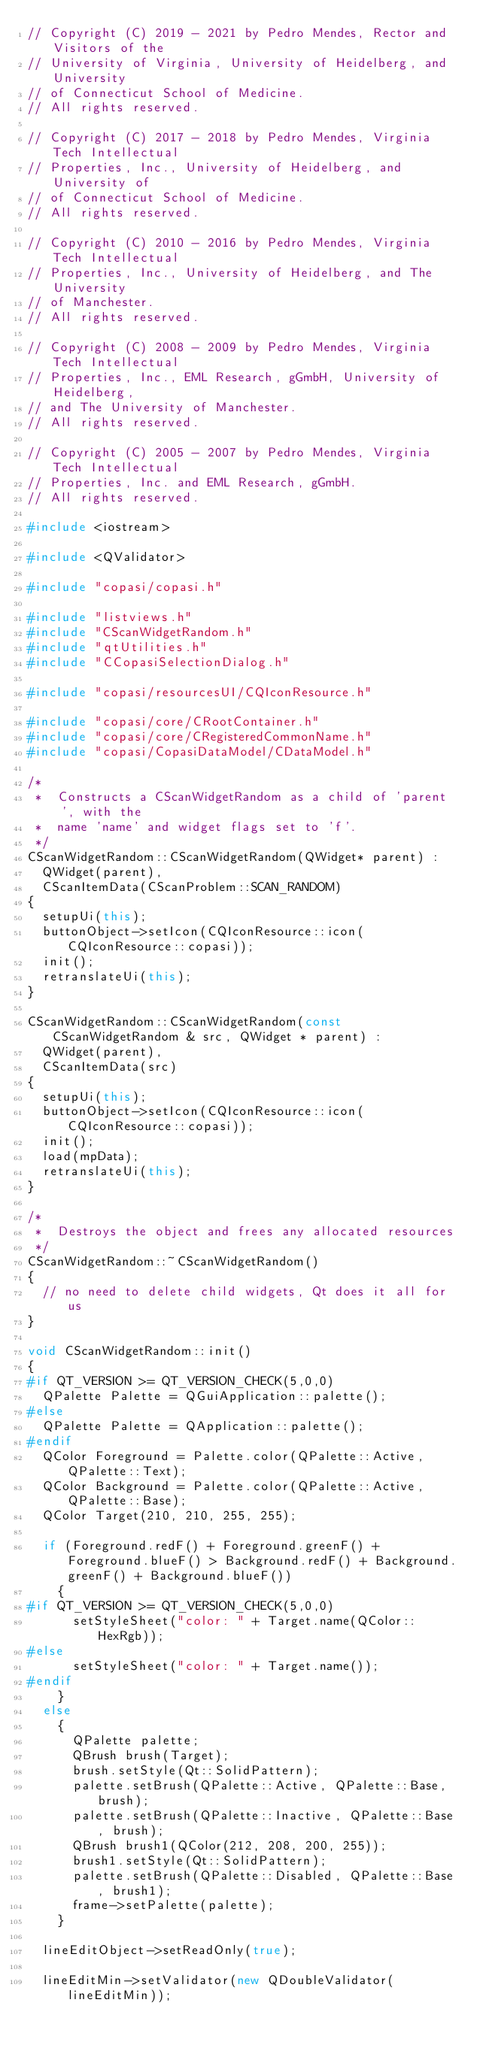<code> <loc_0><loc_0><loc_500><loc_500><_C++_>// Copyright (C) 2019 - 2021 by Pedro Mendes, Rector and Visitors of the
// University of Virginia, University of Heidelberg, and University
// of Connecticut School of Medicine.
// All rights reserved.

// Copyright (C) 2017 - 2018 by Pedro Mendes, Virginia Tech Intellectual
// Properties, Inc., University of Heidelberg, and University of
// of Connecticut School of Medicine.
// All rights reserved.

// Copyright (C) 2010 - 2016 by Pedro Mendes, Virginia Tech Intellectual
// Properties, Inc., University of Heidelberg, and The University
// of Manchester.
// All rights reserved.

// Copyright (C) 2008 - 2009 by Pedro Mendes, Virginia Tech Intellectual
// Properties, Inc., EML Research, gGmbH, University of Heidelberg,
// and The University of Manchester.
// All rights reserved.

// Copyright (C) 2005 - 2007 by Pedro Mendes, Virginia Tech Intellectual
// Properties, Inc. and EML Research, gGmbH.
// All rights reserved.

#include <iostream>

#include <QValidator>

#include "copasi/copasi.h"

#include "listviews.h"
#include "CScanWidgetRandom.h"
#include "qtUtilities.h"
#include "CCopasiSelectionDialog.h"

#include "copasi/resourcesUI/CQIconResource.h"

#include "copasi/core/CRootContainer.h"
#include "copasi/core/CRegisteredCommonName.h"
#include "copasi/CopasiDataModel/CDataModel.h"

/*
 *  Constructs a CScanWidgetRandom as a child of 'parent', with the
 *  name 'name' and widget flags set to 'f'.
 */
CScanWidgetRandom::CScanWidgetRandom(QWidget* parent) :
  QWidget(parent),
  CScanItemData(CScanProblem::SCAN_RANDOM)
{
  setupUi(this);
  buttonObject->setIcon(CQIconResource::icon(CQIconResource::copasi));
  init();
  retranslateUi(this);
}

CScanWidgetRandom::CScanWidgetRandom(const CScanWidgetRandom & src, QWidget * parent) :
  QWidget(parent),
  CScanItemData(src)
{
  setupUi(this);
  buttonObject->setIcon(CQIconResource::icon(CQIconResource::copasi));
  init();
  load(mpData);
  retranslateUi(this);
}

/*
 *  Destroys the object and frees any allocated resources
 */
CScanWidgetRandom::~CScanWidgetRandom()
{
  // no need to delete child widgets, Qt does it all for us
}

void CScanWidgetRandom::init()
{
#if QT_VERSION >= QT_VERSION_CHECK(5,0,0)
  QPalette Palette = QGuiApplication::palette();
#else
  QPalette Palette = QApplication::palette();
#endif
  QColor Foreground = Palette.color(QPalette::Active, QPalette::Text);
  QColor Background = Palette.color(QPalette::Active, QPalette::Base);
  QColor Target(210, 210, 255, 255);

  if (Foreground.redF() + Foreground.greenF() + Foreground.blueF() > Background.redF() + Background.greenF() + Background.blueF())
    {
#if QT_VERSION >= QT_VERSION_CHECK(5,0,0)
      setStyleSheet("color: " + Target.name(QColor::HexRgb));
#else
      setStyleSheet("color: " + Target.name());
#endif
    }
  else
    {
      QPalette palette;
      QBrush brush(Target);
      brush.setStyle(Qt::SolidPattern);
      palette.setBrush(QPalette::Active, QPalette::Base, brush);
      palette.setBrush(QPalette::Inactive, QPalette::Base, brush);
      QBrush brush1(QColor(212, 208, 200, 255));
      brush1.setStyle(Qt::SolidPattern);
      palette.setBrush(QPalette::Disabled, QPalette::Base, brush1);
      frame->setPalette(palette);
    }

  lineEditObject->setReadOnly(true);

  lineEditMin->setValidator(new QDoubleValidator(lineEditMin));</code> 